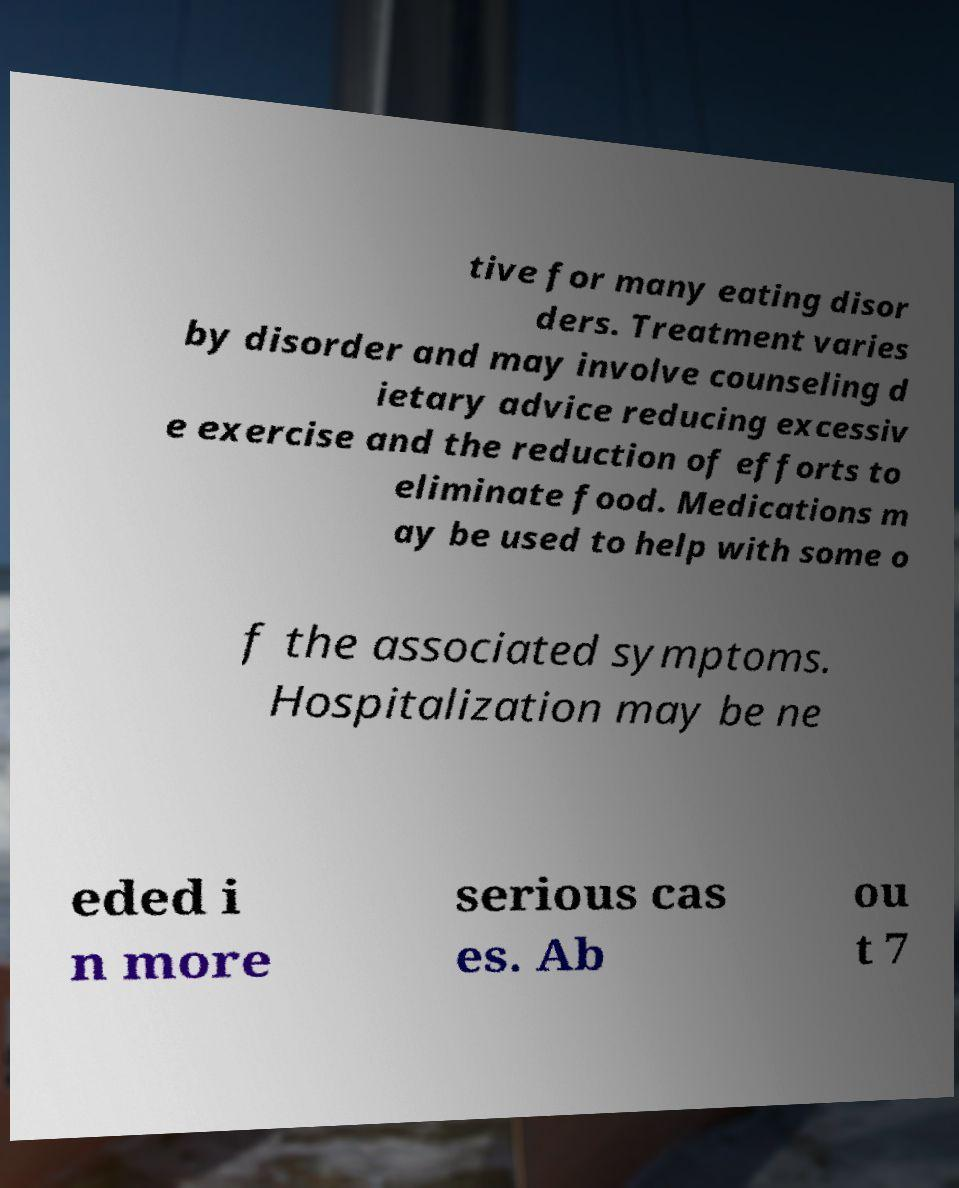Could you assist in decoding the text presented in this image and type it out clearly? tive for many eating disor ders. Treatment varies by disorder and may involve counseling d ietary advice reducing excessiv e exercise and the reduction of efforts to eliminate food. Medications m ay be used to help with some o f the associated symptoms. Hospitalization may be ne eded i n more serious cas es. Ab ou t 7 